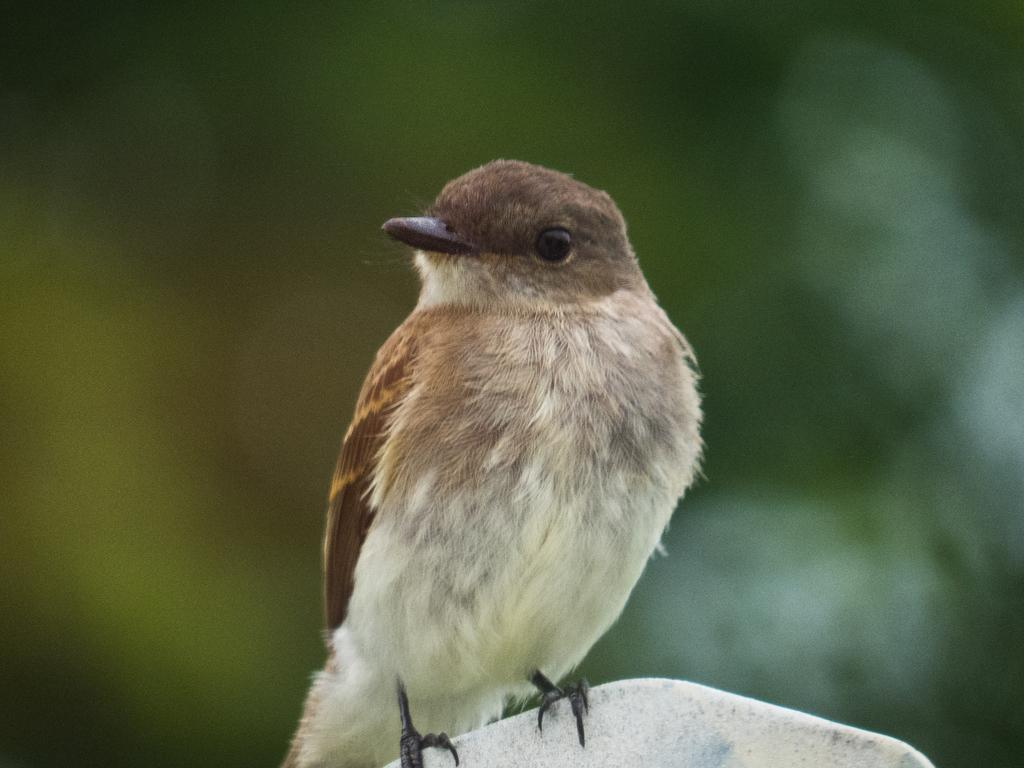What type of animal is in the image? There is a bird in the image. Can you describe the bird's coloring? The bird has brown, black, and cream colors. What is the bird sitting on in the image? The bird is on a white-colored object. What can be seen in the background of the image? There are green-colored objects in the background of the image. How are the green-colored objects depicted in the image? The green-colored objects are blurry. Where is the self-serve lunchroom located in the image? There is no self-serve lunchroom present in the image. What type of crime is the crook committing in the image? There is no crook or crime depicted in the image; it features a bird on a white-colored object with green-colored objects in the background. 